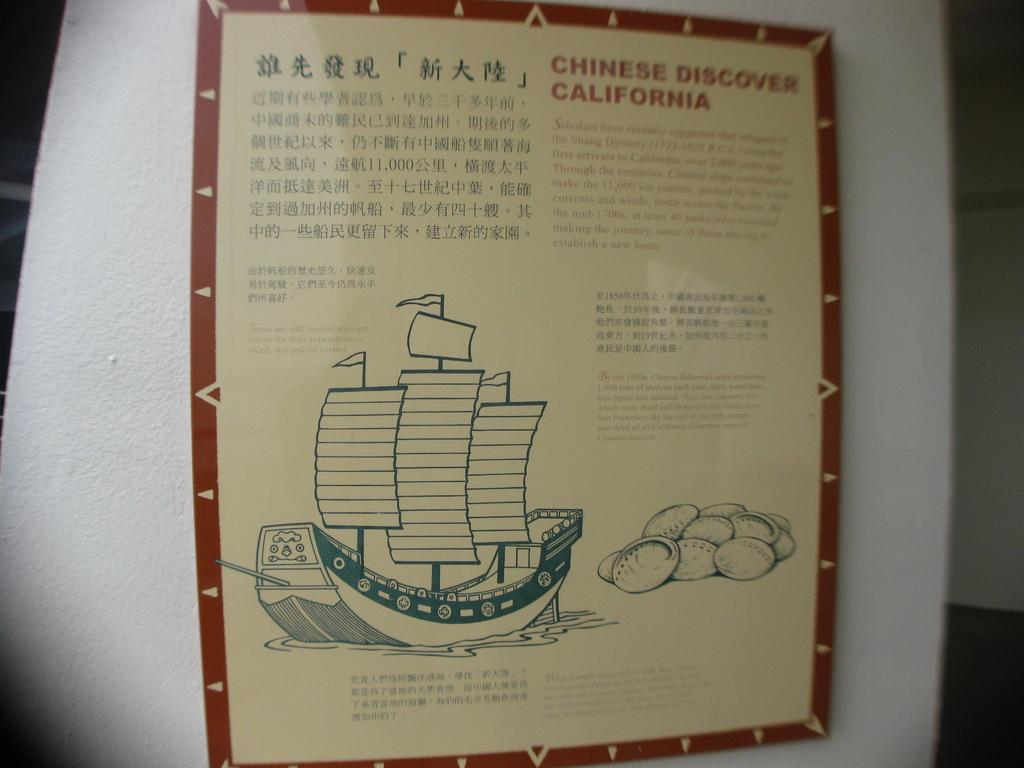<image>
Create a compact narrative representing the image presented. A educational flyer for the Chinese Discover California 